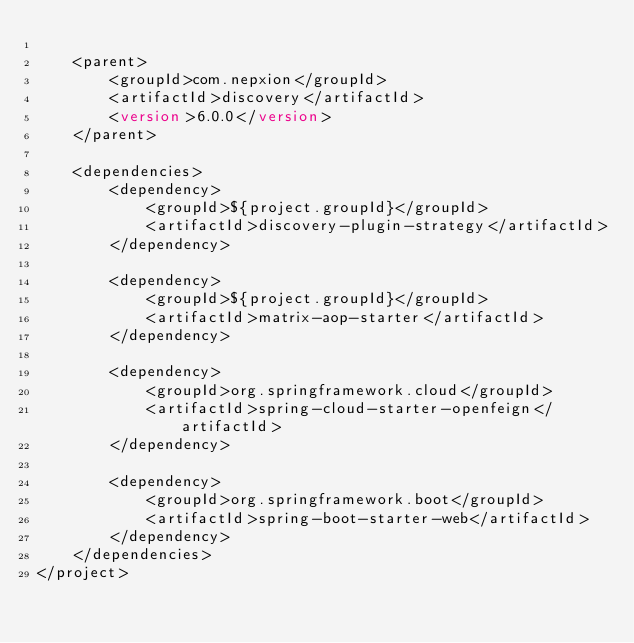<code> <loc_0><loc_0><loc_500><loc_500><_XML_>
    <parent>
        <groupId>com.nepxion</groupId>
        <artifactId>discovery</artifactId>
        <version>6.0.0</version>
    </parent>

    <dependencies>
        <dependency>
            <groupId>${project.groupId}</groupId>
            <artifactId>discovery-plugin-strategy</artifactId>
        </dependency>

        <dependency>
            <groupId>${project.groupId}</groupId>
            <artifactId>matrix-aop-starter</artifactId>
        </dependency>

        <dependency>
            <groupId>org.springframework.cloud</groupId>
            <artifactId>spring-cloud-starter-openfeign</artifactId>
        </dependency>

        <dependency>
            <groupId>org.springframework.boot</groupId>
            <artifactId>spring-boot-starter-web</artifactId>
        </dependency>
    </dependencies>
</project></code> 